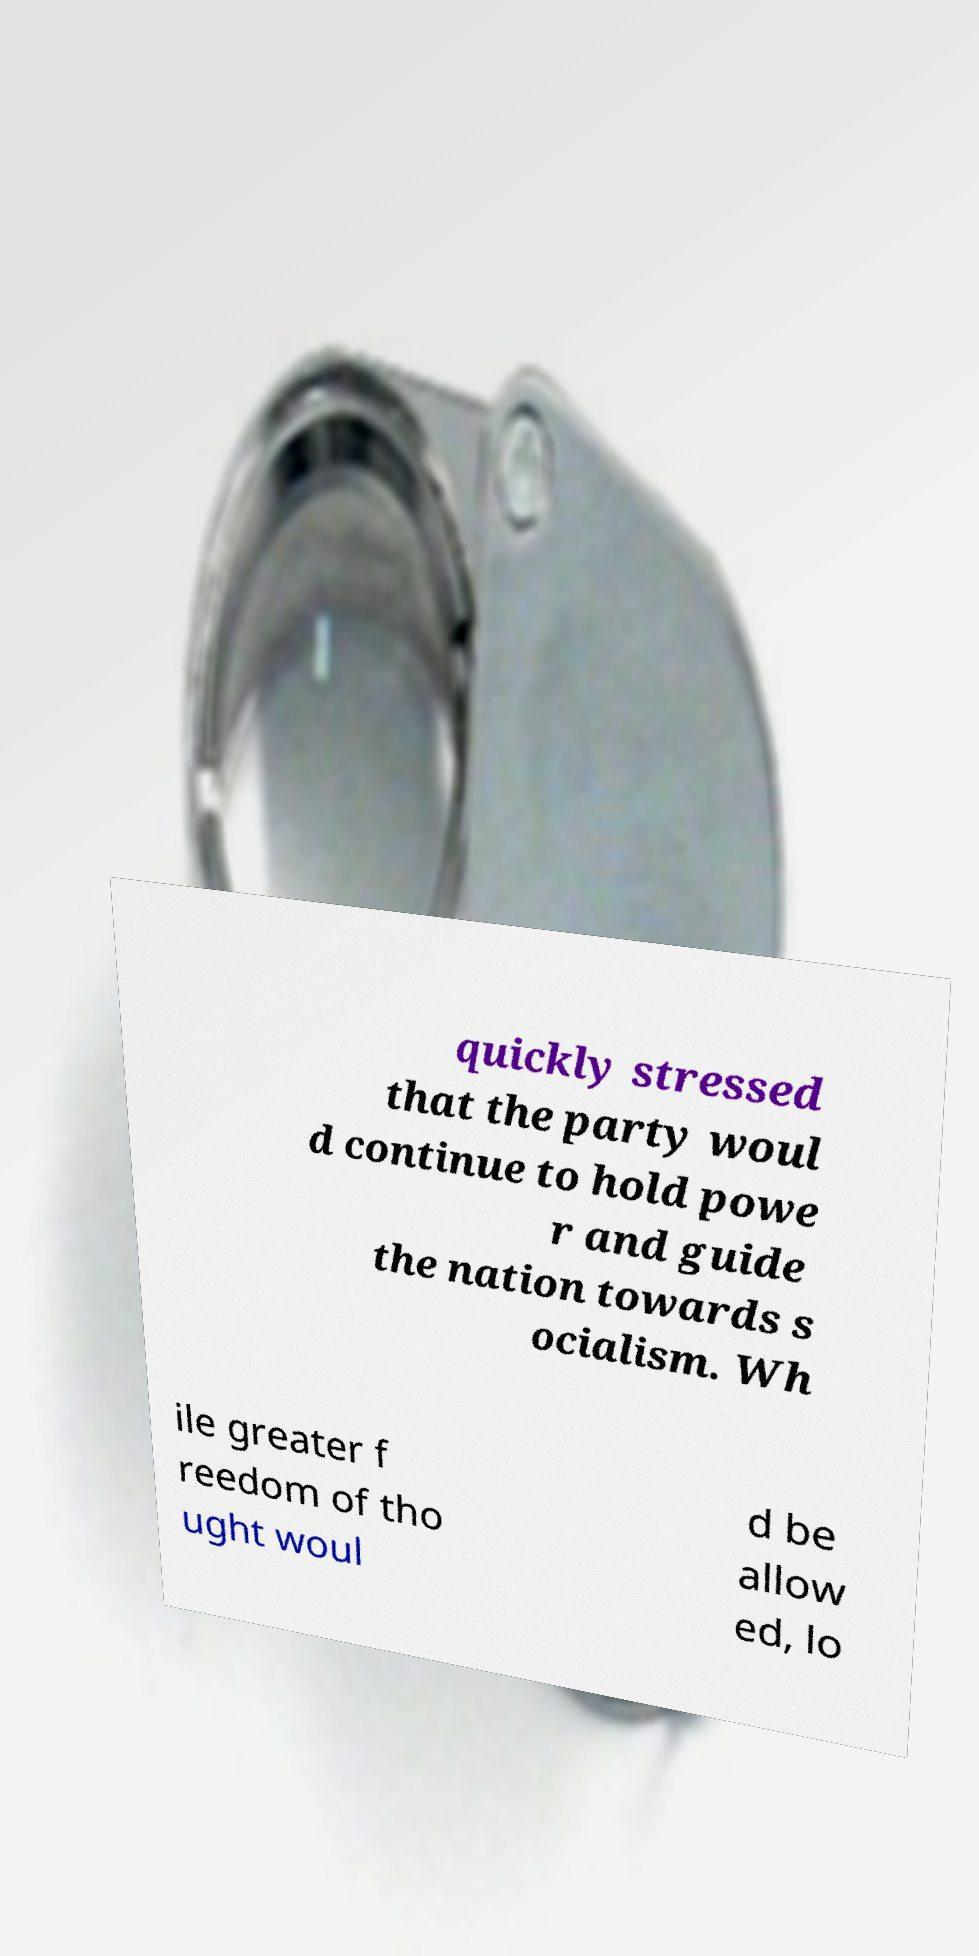Can you accurately transcribe the text from the provided image for me? quickly stressed that the party woul d continue to hold powe r and guide the nation towards s ocialism. Wh ile greater f reedom of tho ught woul d be allow ed, lo 